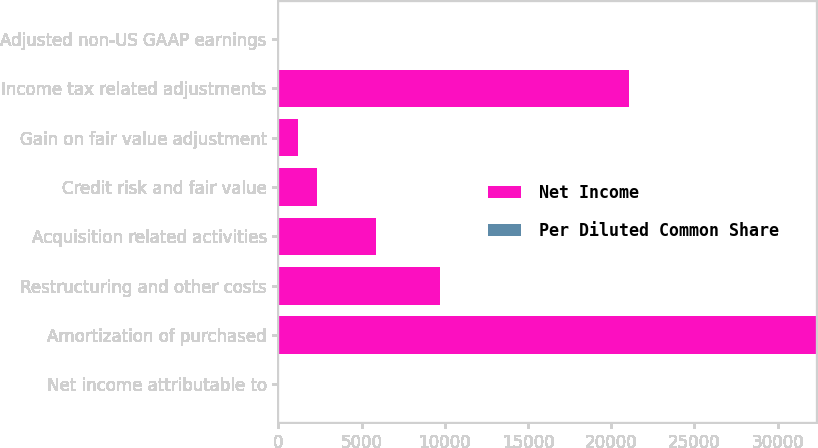Convert chart to OTSL. <chart><loc_0><loc_0><loc_500><loc_500><stacked_bar_chart><ecel><fcel>Net income attributable to<fcel>Amortization of purchased<fcel>Restructuring and other costs<fcel>Acquisition related activities<fcel>Credit risk and fair value<fcel>Gain on fair value adjustment<fcel>Income tax related adjustments<fcel>Adjusted non-US GAAP earnings<nl><fcel>Net Income<fcel>2.255<fcel>32309<fcel>9721<fcel>5890<fcel>2339<fcel>1200<fcel>21054<fcel>2.255<nl><fcel>Per Diluted Common Share<fcel>2.16<fcel>0.22<fcel>0.07<fcel>0.04<fcel>0.02<fcel>0.01<fcel>0.15<fcel>2.35<nl></chart> 